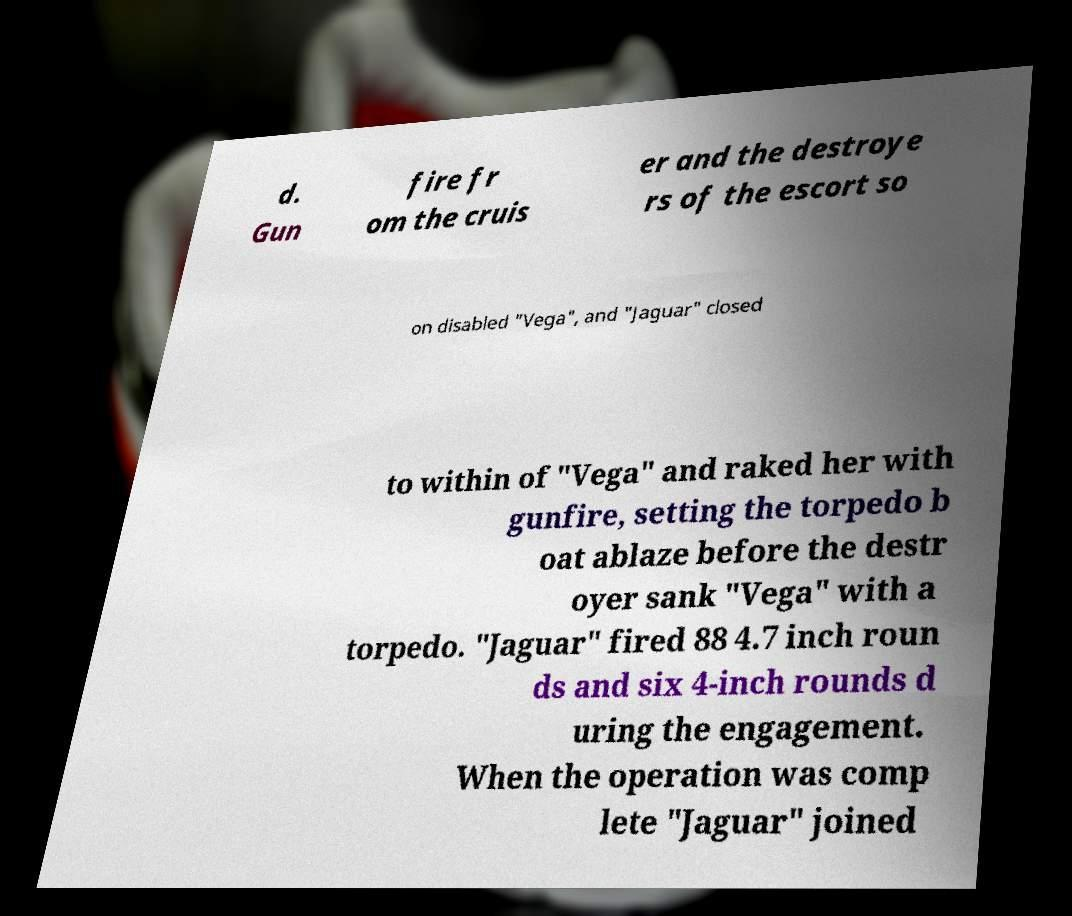Could you extract and type out the text from this image? d. Gun fire fr om the cruis er and the destroye rs of the escort so on disabled "Vega", and "Jaguar" closed to within of "Vega" and raked her with gunfire, setting the torpedo b oat ablaze before the destr oyer sank "Vega" with a torpedo. "Jaguar" fired 88 4.7 inch roun ds and six 4-inch rounds d uring the engagement. When the operation was comp lete "Jaguar" joined 